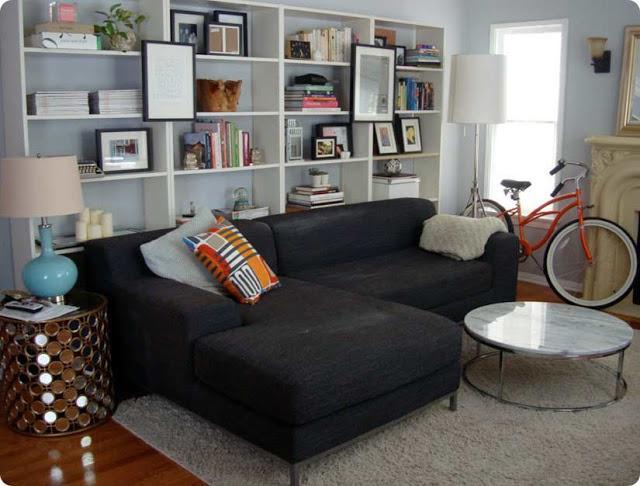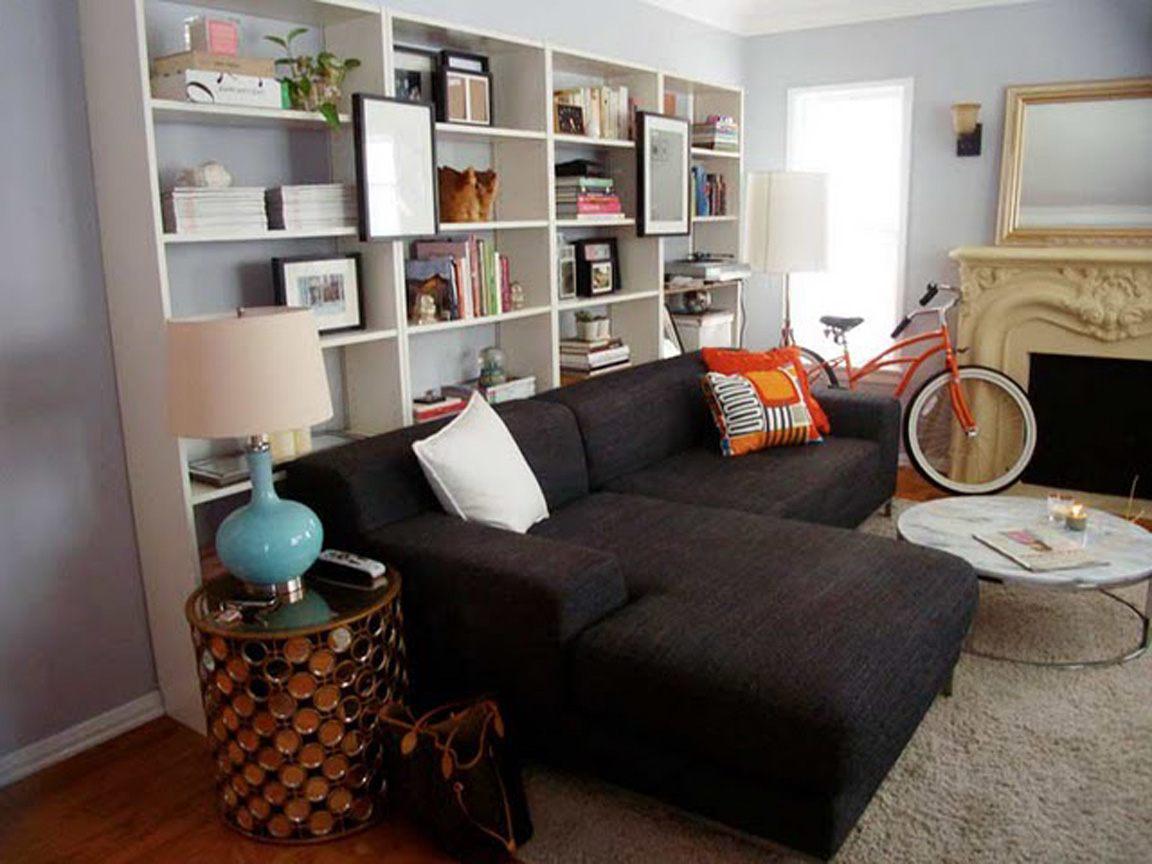The first image is the image on the left, the second image is the image on the right. Evaluate the accuracy of this statement regarding the images: "An image shows a dark sectional couch with a white pillow on one end and patterned and orange pillows on the other end.". Is it true? Answer yes or no. Yes. The first image is the image on the left, the second image is the image on the right. Assess this claim about the two images: "In each image, a standard sized sofa with extra throw pillows and a coffee table in front of it sits parallel to a wall shelving unit.". Correct or not? Answer yes or no. No. 